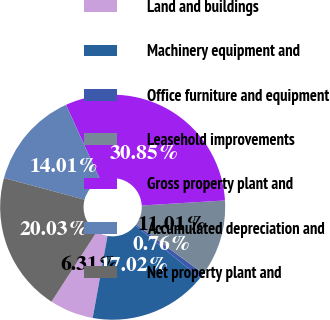<chart> <loc_0><loc_0><loc_500><loc_500><pie_chart><fcel>Land and buildings<fcel>Machinery equipment and<fcel>Office furniture and equipment<fcel>Leasehold improvements<fcel>Gross property plant and<fcel>Accumulated depreciation and<fcel>Net property plant and<nl><fcel>6.31%<fcel>17.02%<fcel>0.76%<fcel>11.01%<fcel>30.85%<fcel>14.01%<fcel>20.03%<nl></chart> 